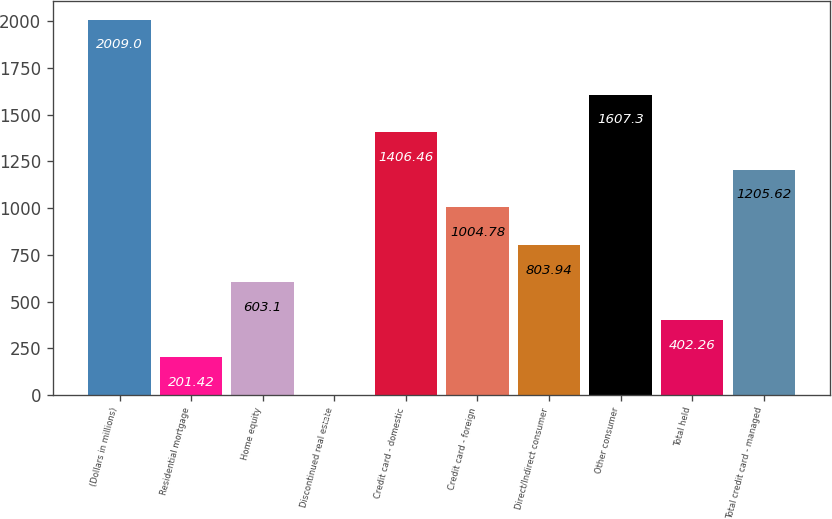<chart> <loc_0><loc_0><loc_500><loc_500><bar_chart><fcel>(Dollars in millions)<fcel>Residential mortgage<fcel>Home equity<fcel>Discontinued real estate<fcel>Credit card - domestic<fcel>Credit card - foreign<fcel>Direct/Indirect consumer<fcel>Other consumer<fcel>Total held<fcel>Total credit card - managed<nl><fcel>2009<fcel>201.42<fcel>603.1<fcel>0.58<fcel>1406.46<fcel>1004.78<fcel>803.94<fcel>1607.3<fcel>402.26<fcel>1205.62<nl></chart> 